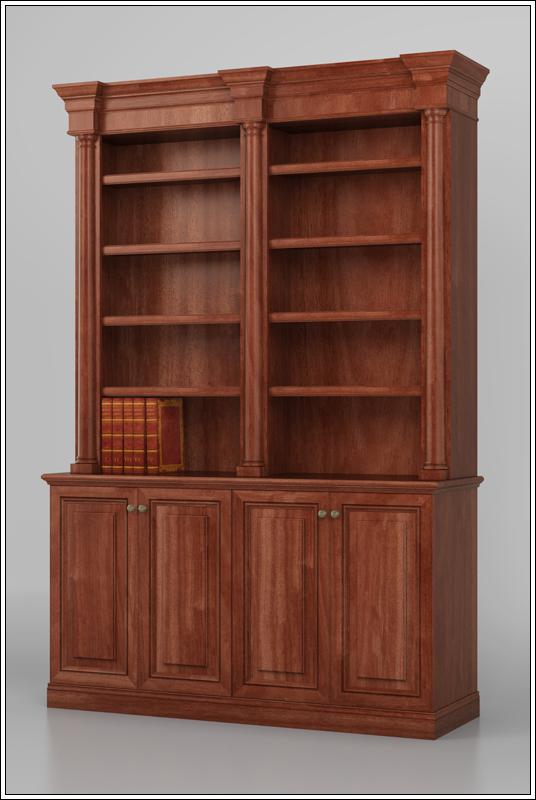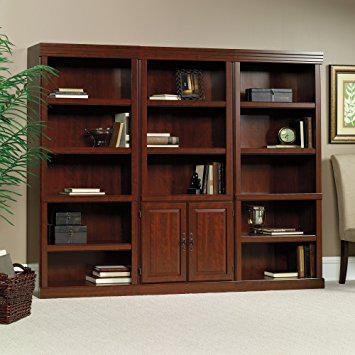The first image is the image on the left, the second image is the image on the right. Assess this claim about the two images: "A bookcase in one image has three side-by-side upper shelf units over six solid doors.". Correct or not? Answer yes or no. No. The first image is the image on the left, the second image is the image on the right. Considering the images on both sides, is "The shelves have no objects resting on them." valid? Answer yes or no. No. 